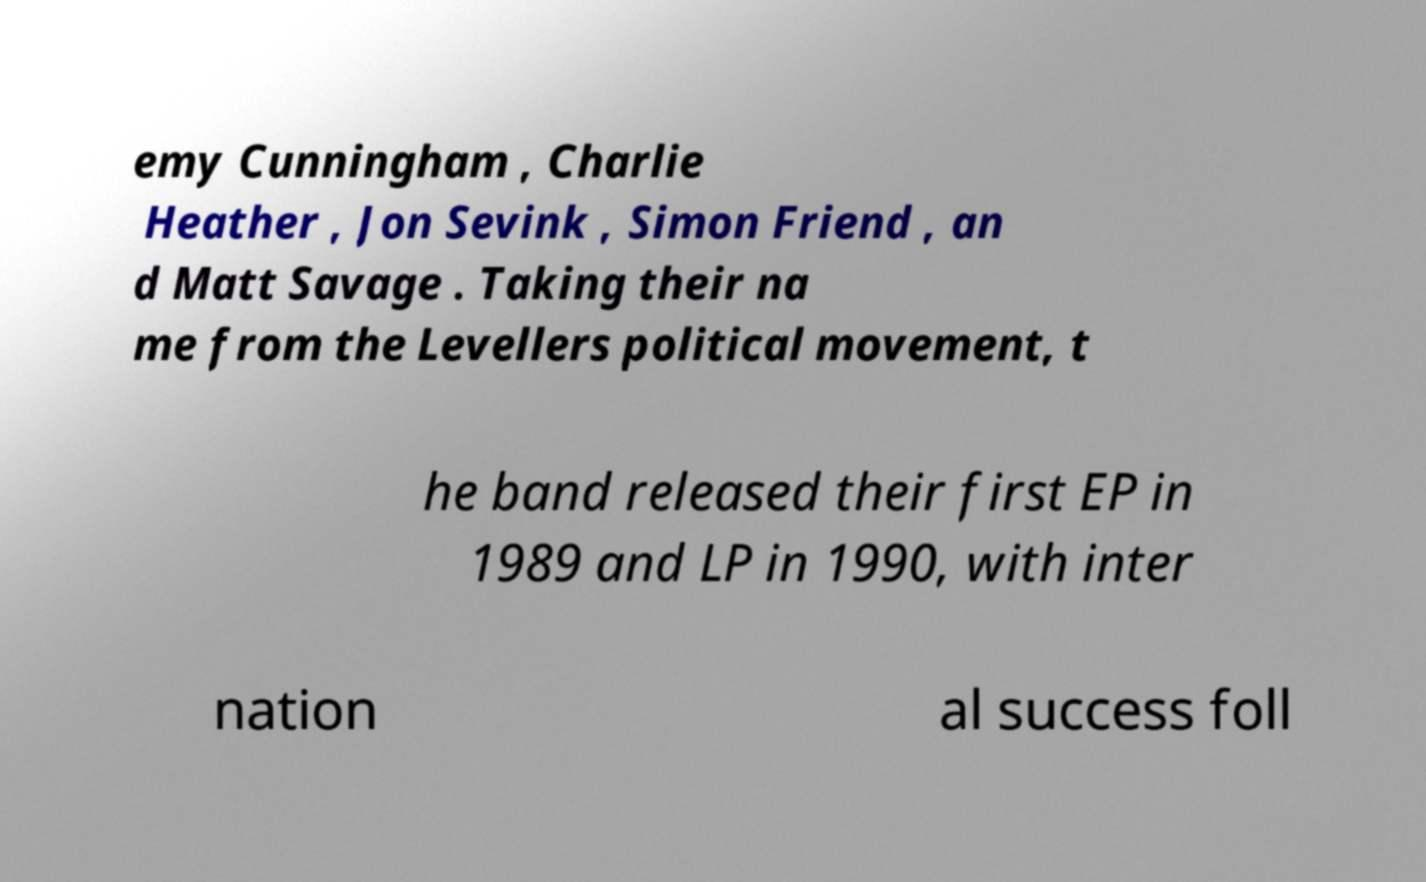For documentation purposes, I need the text within this image transcribed. Could you provide that? emy Cunningham , Charlie Heather , Jon Sevink , Simon Friend , an d Matt Savage . Taking their na me from the Levellers political movement, t he band released their first EP in 1989 and LP in 1990, with inter nation al success foll 